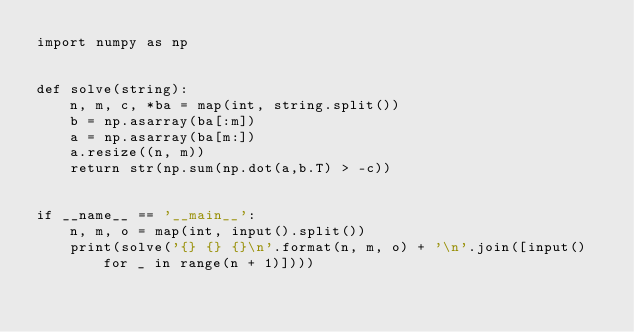<code> <loc_0><loc_0><loc_500><loc_500><_Python_>import numpy as np


def solve(string):
    n, m, c, *ba = map(int, string.split())
    b = np.asarray(ba[:m])
    a = np.asarray(ba[m:])
    a.resize((n, m))
    return str(np.sum(np.dot(a,b.T) > -c))


if __name__ == '__main__':
    n, m, o = map(int, input().split())
    print(solve('{} {} {}\n'.format(n, m, o) + '\n'.join([input() for _ in range(n + 1)])))
</code> 